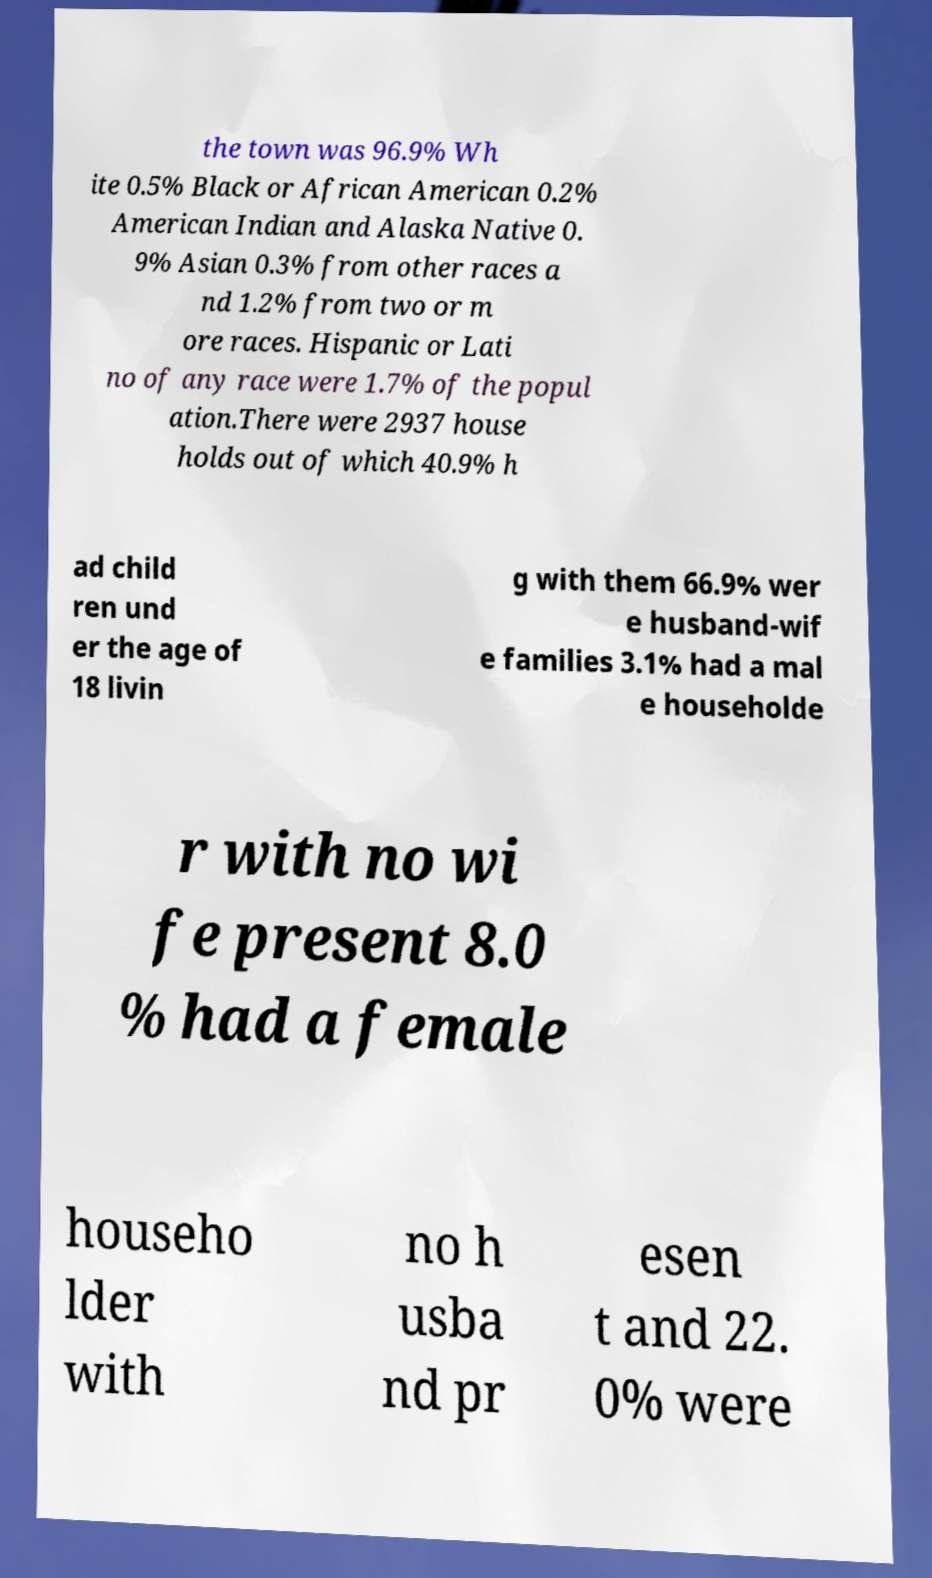Please identify and transcribe the text found in this image. the town was 96.9% Wh ite 0.5% Black or African American 0.2% American Indian and Alaska Native 0. 9% Asian 0.3% from other races a nd 1.2% from two or m ore races. Hispanic or Lati no of any race were 1.7% of the popul ation.There were 2937 house holds out of which 40.9% h ad child ren und er the age of 18 livin g with them 66.9% wer e husband-wif e families 3.1% had a mal e householde r with no wi fe present 8.0 % had a female househo lder with no h usba nd pr esen t and 22. 0% were 